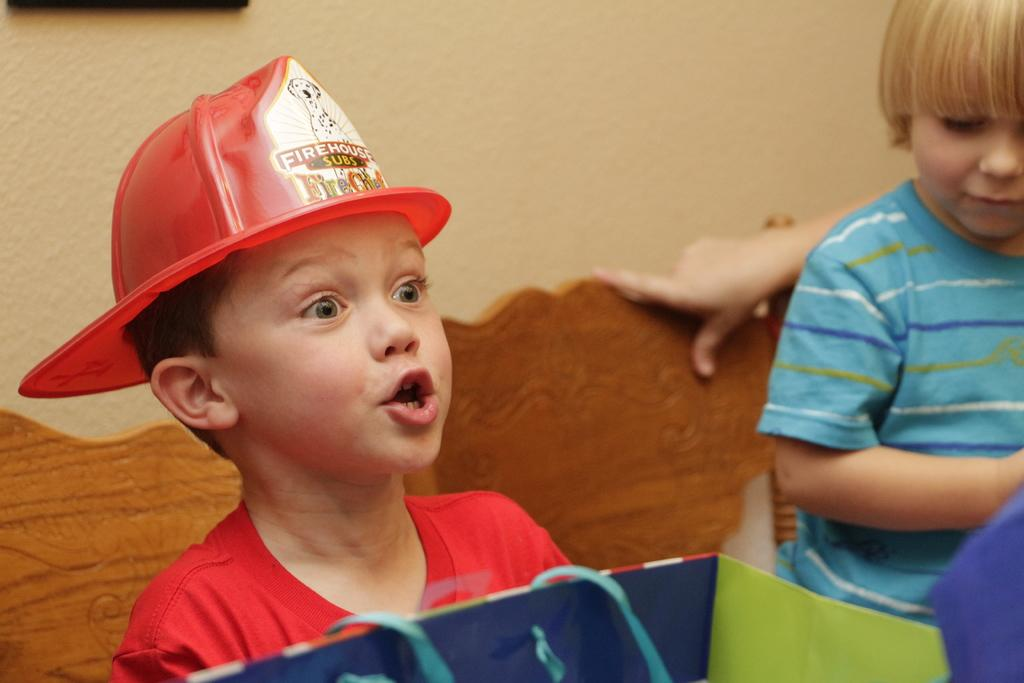How many kids are present in the image? There are two kids in the image. Can you describe the presence of a person in the image? There is a hand of a person visible in the image. What other items or objects can be seen in the image? There are some objects in the image. What is visible in the background of the image? There is a wall in the background of the image. What type of plantation can be seen in the image? There is no plantation present in the image. How does the kite sense the wind in the image? There is no kite present in the image, so it is not possible to determine how it might sense the wind. 